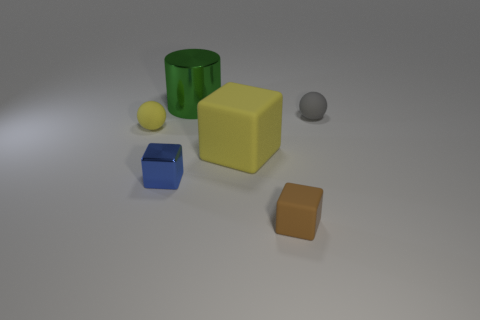Add 2 green cylinders. How many objects exist? 8 Subtract all spheres. How many objects are left? 4 Subtract 0 cyan balls. How many objects are left? 6 Subtract all large green metal cylinders. Subtract all green shiny things. How many objects are left? 4 Add 4 gray objects. How many gray objects are left? 5 Add 6 large blue balls. How many large blue balls exist? 6 